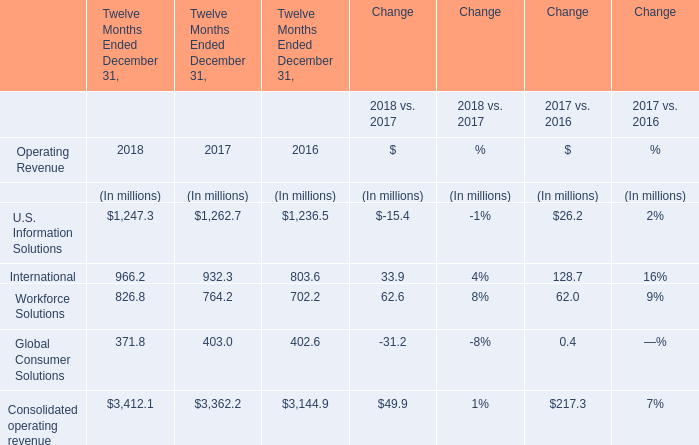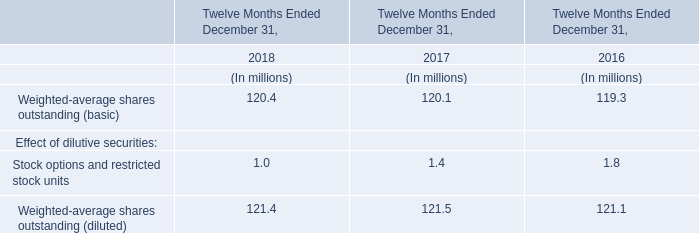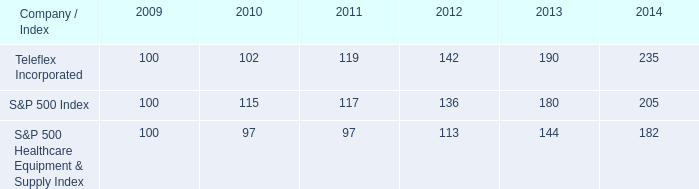what is the rate of return of an investment in teleflex incorporated from 2009 to 2010? 
Computations: ((102 - 100) / 100)
Answer: 0.02. 